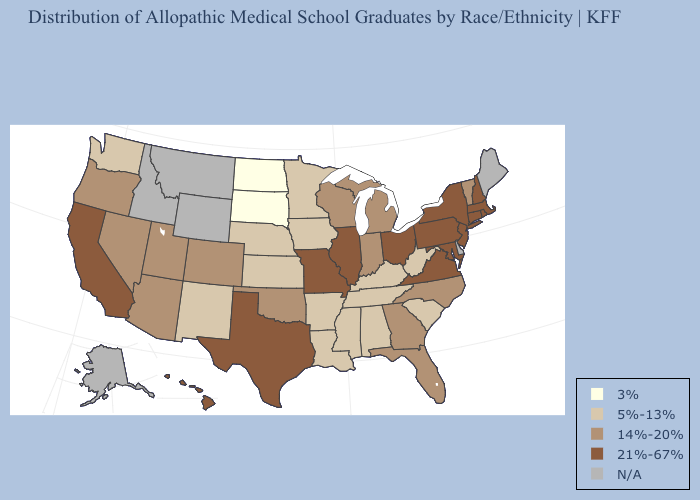Does South Dakota have the highest value in the USA?
Answer briefly. No. Name the states that have a value in the range 3%?
Keep it brief. North Dakota, South Dakota. Does the map have missing data?
Write a very short answer. Yes. Does Arkansas have the highest value in the USA?
Concise answer only. No. Name the states that have a value in the range 3%?
Be succinct. North Dakota, South Dakota. Which states have the highest value in the USA?
Write a very short answer. California, Connecticut, Hawaii, Illinois, Maryland, Massachusetts, Missouri, New Hampshire, New Jersey, New York, Ohio, Pennsylvania, Rhode Island, Texas, Virginia. What is the value of North Dakota?
Short answer required. 3%. Does Massachusetts have the highest value in the USA?
Keep it brief. Yes. What is the value of Michigan?
Short answer required. 14%-20%. Name the states that have a value in the range 14%-20%?
Short answer required. Arizona, Colorado, Florida, Georgia, Indiana, Michigan, Nevada, North Carolina, Oklahoma, Oregon, Utah, Vermont, Wisconsin. Which states have the lowest value in the South?
Quick response, please. Alabama, Arkansas, Kentucky, Louisiana, Mississippi, South Carolina, Tennessee, West Virginia. Does Hawaii have the lowest value in the USA?
Be succinct. No. What is the value of Tennessee?
Give a very brief answer. 5%-13%. Which states have the lowest value in the USA?
Keep it brief. North Dakota, South Dakota. 